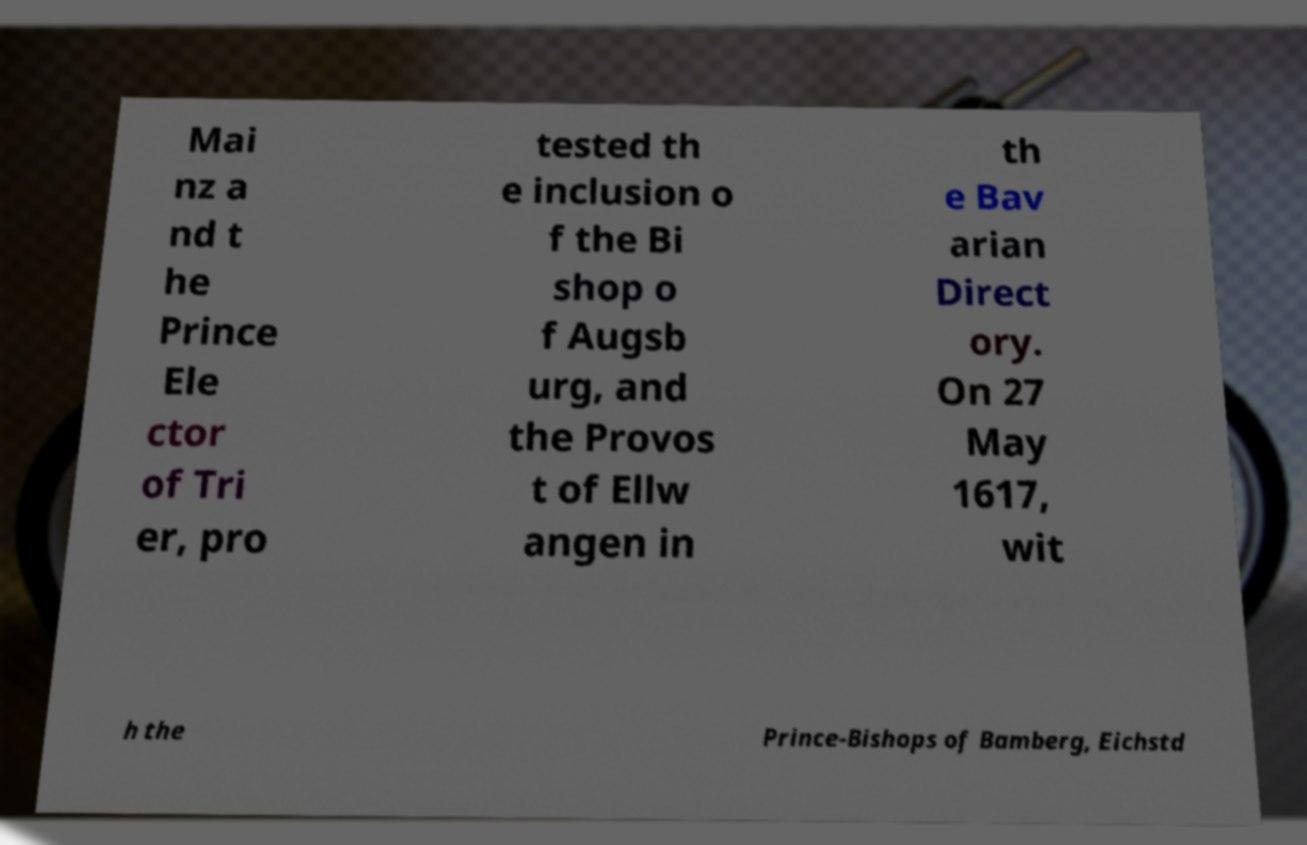Can you read and provide the text displayed in the image?This photo seems to have some interesting text. Can you extract and type it out for me? Mai nz a nd t he Prince Ele ctor of Tri er, pro tested th e inclusion o f the Bi shop o f Augsb urg, and the Provos t of Ellw angen in th e Bav arian Direct ory. On 27 May 1617, wit h the Prince-Bishops of Bamberg, Eichstd 